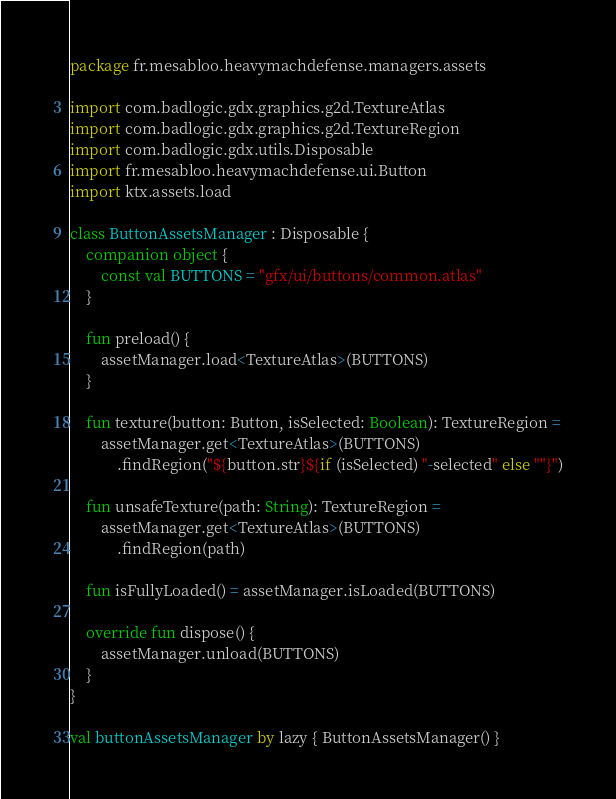<code> <loc_0><loc_0><loc_500><loc_500><_Kotlin_>package fr.mesabloo.heavymachdefense.managers.assets

import com.badlogic.gdx.graphics.g2d.TextureAtlas
import com.badlogic.gdx.graphics.g2d.TextureRegion
import com.badlogic.gdx.utils.Disposable
import fr.mesabloo.heavymachdefense.ui.Button
import ktx.assets.load

class ButtonAssetsManager : Disposable {
    companion object {
        const val BUTTONS = "gfx/ui/buttons/common.atlas"
    }

    fun preload() {
        assetManager.load<TextureAtlas>(BUTTONS)
    }

    fun texture(button: Button, isSelected: Boolean): TextureRegion =
        assetManager.get<TextureAtlas>(BUTTONS)
            .findRegion("${button.str}${if (isSelected) "-selected" else ""}")

    fun unsafeTexture(path: String): TextureRegion =
        assetManager.get<TextureAtlas>(BUTTONS)
            .findRegion(path)

    fun isFullyLoaded() = assetManager.isLoaded(BUTTONS)

    override fun dispose() {
        assetManager.unload(BUTTONS)
    }
}

val buttonAssetsManager by lazy { ButtonAssetsManager() }</code> 